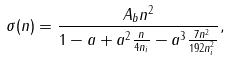<formula> <loc_0><loc_0><loc_500><loc_500>\sigma ( n ) = \frac { A _ { b } n ^ { 2 } } { 1 - a + a ^ { 2 } \frac { n } { 4 n _ { i } } - a ^ { 3 } \frac { 7 n ^ { 2 } } { 1 9 2 n ^ { 2 } _ { i } } } ,</formula> 